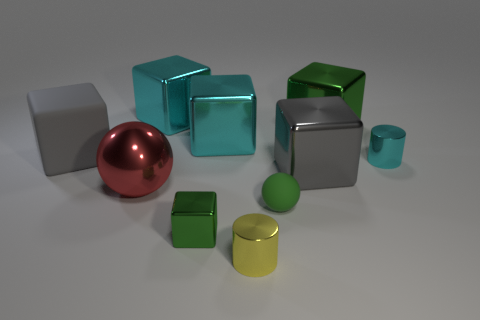There is a yellow object that is the same size as the green sphere; what is its material?
Your response must be concise. Metal. There is a big green thing; are there any metallic balls behind it?
Offer a very short reply. No. Are there an equal number of gray shiny things in front of the yellow thing and gray shiny cylinders?
Ensure brevity in your answer.  Yes. What is the shape of the cyan shiny thing that is the same size as the yellow metallic cylinder?
Provide a succinct answer. Cylinder. What is the red sphere made of?
Offer a very short reply. Metal. What is the color of the big metallic thing that is both in front of the big rubber thing and right of the big metal sphere?
Ensure brevity in your answer.  Gray. Are there the same number of large matte cubes behind the large green object and tiny cylinders on the left side of the small green matte sphere?
Your answer should be very brief. No. There is a small cylinder that is made of the same material as the small yellow object; what is its color?
Your answer should be compact. Cyan. Is the color of the big rubber object the same as the small cylinder that is in front of the red metal sphere?
Your answer should be compact. No. Is there a tiny green block that is behind the green metal block that is behind the green metallic block in front of the red shiny sphere?
Provide a succinct answer. No. 